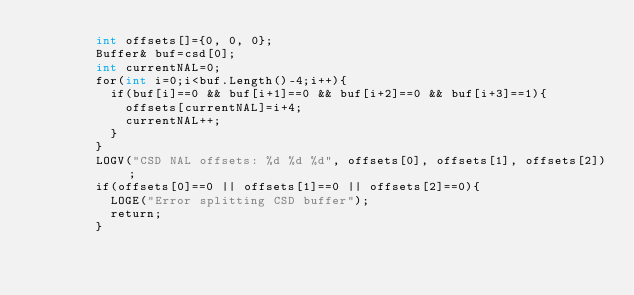Convert code to text. <code><loc_0><loc_0><loc_500><loc_500><_ObjectiveC_>    		int offsets[]={0, 0, 0};
    		Buffer& buf=csd[0];
    		int currentNAL=0;
    		for(int i=0;i<buf.Length()-4;i++){
    			if(buf[i]==0 && buf[i+1]==0 && buf[i+2]==0 && buf[i+3]==1){
    				offsets[currentNAL]=i+4;
    				currentNAL++;
    			}
    		}
    		LOGV("CSD NAL offsets: %d %d %d", offsets[0], offsets[1], offsets[2]);
    		if(offsets[0]==0 || offsets[1]==0 || offsets[2]==0){
    			LOGE("Error splitting CSD buffer");
    			return;
    		}</code> 